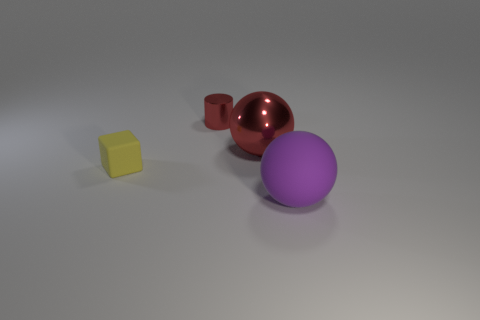Is the material of the sphere behind the matte ball the same as the tiny yellow cube?
Give a very brief answer. No. There is a tiny metallic cylinder; is it the same color as the ball that is to the left of the purple rubber ball?
Offer a terse response. Yes. There is a tiny yellow matte thing; are there any large red shiny balls behind it?
Provide a short and direct response. Yes. There is a matte thing left of the large purple sphere; is it the same size as the thing that is in front of the tiny yellow matte block?
Give a very brief answer. No. Are there any blocks that have the same size as the cylinder?
Ensure brevity in your answer.  Yes. There is a red object that is on the right side of the red metal cylinder; is its shape the same as the purple object?
Offer a very short reply. Yes. There is a object in front of the small matte object; what is it made of?
Your answer should be compact. Rubber. There is a big matte thing that is right of the large sphere that is on the left side of the large purple ball; what is its shape?
Give a very brief answer. Sphere. There is a large shiny thing; does it have the same shape as the small object behind the tiny matte object?
Keep it short and to the point. No. What number of purple matte things are in front of the small object that is in front of the small cylinder?
Your answer should be very brief. 1. 